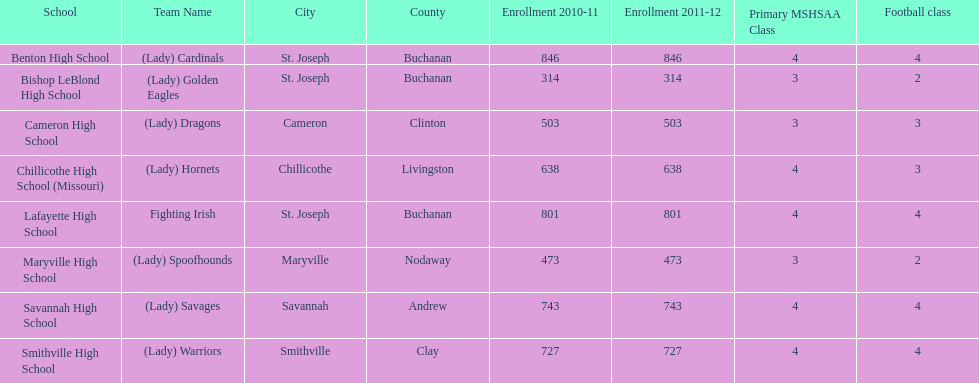Which school has the least amount of student enrollment between 2010-2011 and 2011-2012? Bishop LeBlond High School. 